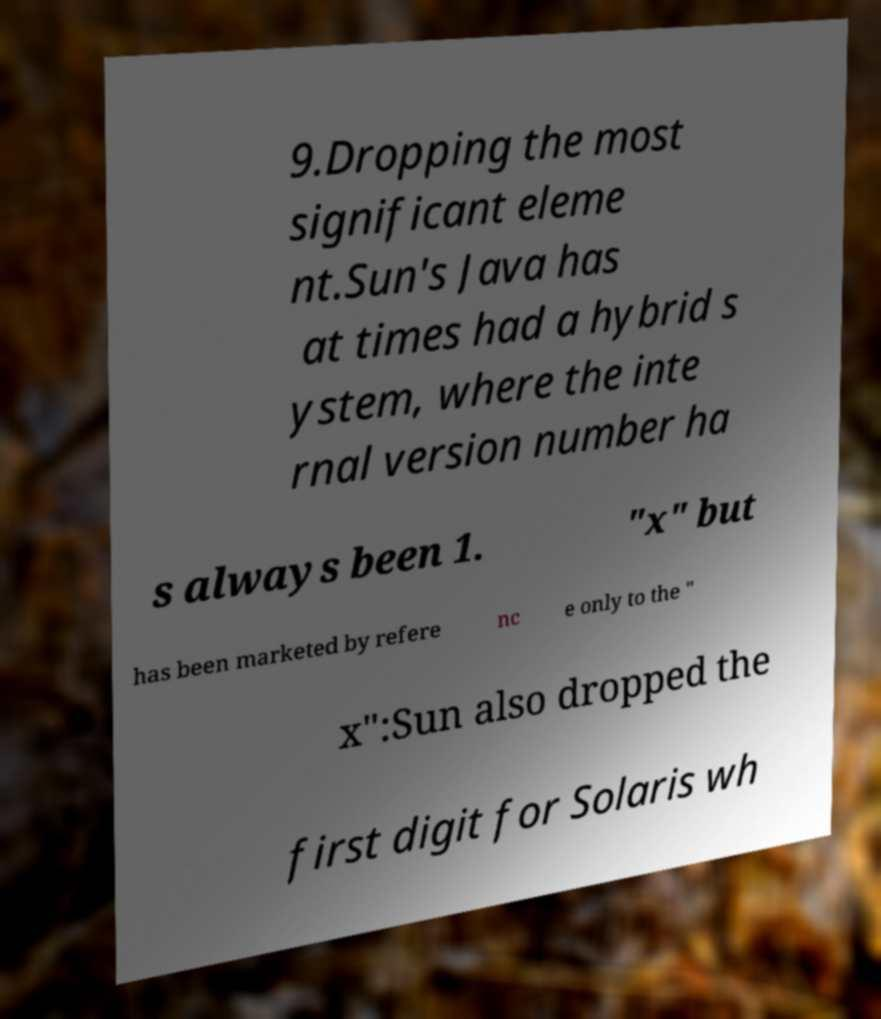Please read and relay the text visible in this image. What does it say? 9.Dropping the most significant eleme nt.Sun's Java has at times had a hybrid s ystem, where the inte rnal version number ha s always been 1. "x" but has been marketed by refere nc e only to the " x":Sun also dropped the first digit for Solaris wh 